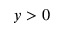<formula> <loc_0><loc_0><loc_500><loc_500>y > 0</formula> 